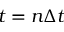Convert formula to latex. <formula><loc_0><loc_0><loc_500><loc_500>t = n \Delta t</formula> 